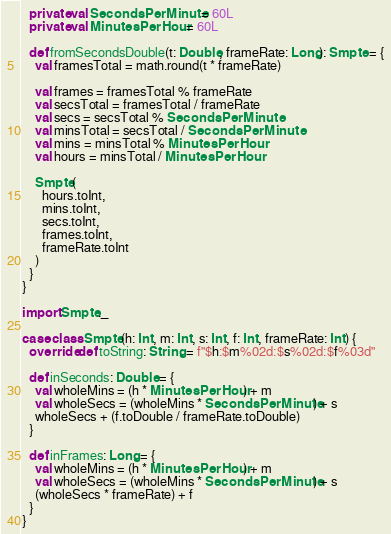Convert code to text. <code><loc_0><loc_0><loc_500><loc_500><_Scala_>  private val SecondsPerMinute = 60L
  private val MinutesPerHour = 60L

  def fromSecondsDouble(t: Double, frameRate: Long): Smpte = {
    val framesTotal = math.round(t * frameRate)

    val frames = framesTotal % frameRate
    val secsTotal = framesTotal / frameRate
    val secs = secsTotal % SecondsPerMinute
    val minsTotal = secsTotal / SecondsPerMinute
    val mins = minsTotal % MinutesPerHour
    val hours = minsTotal / MinutesPerHour

    Smpte(
      hours.toInt,
      mins.toInt,
      secs.toInt,
      frames.toInt,
      frameRate.toInt
    )
  }
}

import Smpte._

case class Smpte(h: Int, m: Int, s: Int, f: Int, frameRate: Int) {
  override def toString: String = f"$h:$m%02d:$s%02d:$f%03d"

  def inSeconds: Double = {
    val wholeMins = (h * MinutesPerHour) + m
    val wholeSecs = (wholeMins * SecondsPerMinute) + s
    wholeSecs + (f.toDouble / frameRate.toDouble)
  }

  def inFrames: Long = {
    val wholeMins = (h * MinutesPerHour) + m
    val wholeSecs = (wholeMins * SecondsPerMinute) + s
    (wholeSecs * frameRate) + f
  }
}
</code> 